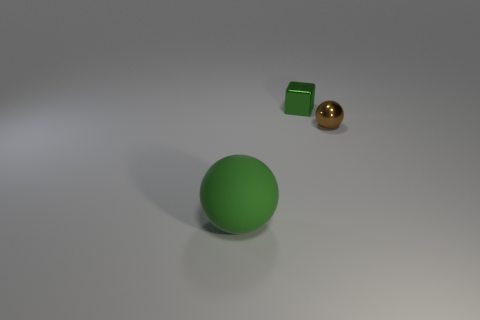There is a object to the left of the small block; does it have the same color as the small shiny cube?
Give a very brief answer. Yes. What material is the other brown thing that is the same shape as the large object?
Your response must be concise. Metal. Is there any other thing that has the same material as the big thing?
Offer a terse response. No. How many cylinders are either big blue metallic objects or large rubber objects?
Provide a succinct answer. 0. There is a sphere right of the matte sphere; is it the same size as the green object that is in front of the cube?
Your response must be concise. No. What is the ball that is behind the sphere that is on the left side of the small sphere made of?
Keep it short and to the point. Metal. Are there fewer big green things that are behind the large object than red shiny balls?
Your response must be concise. No. There is another object that is the same material as the tiny brown thing; what shape is it?
Give a very brief answer. Cube. What number of other objects are there of the same shape as the brown object?
Provide a short and direct response. 1. How many cyan things are large balls or tiny spheres?
Give a very brief answer. 0. 